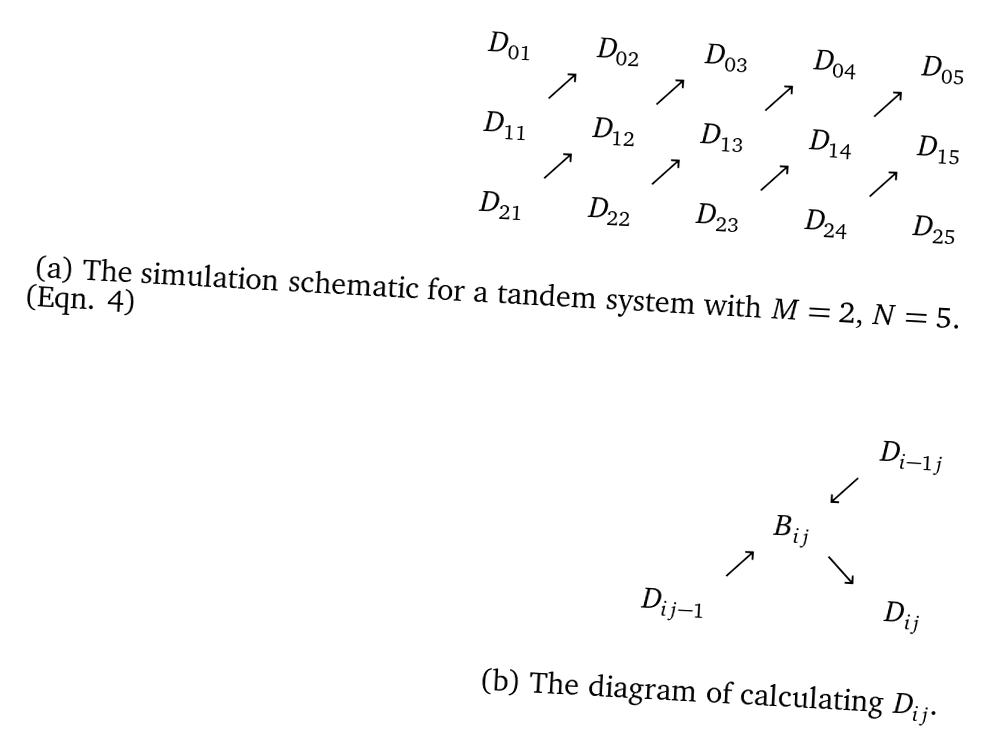Convert formula to latex. <formula><loc_0><loc_0><loc_500><loc_500>\begin{array} { c c c c c c c c c } D _ { 0 1 } & & D _ { 0 2 } & & D _ { 0 3 } & & D _ { 0 4 } & & D _ { 0 5 } \\ & \nearrow & & \nearrow & & \nearrow & & \nearrow & \\ D _ { 1 1 } & & D _ { 1 2 } & & D _ { 1 3 } & & D _ { 1 4 } & & D _ { 1 5 } \\ & \nearrow & & \nearrow & & \nearrow & & \nearrow & \\ D _ { 2 1 } & & D _ { 2 2 } & & D _ { 2 3 } & & D _ { 2 4 } & & D _ { 2 5 } \end{array} \\ \\ \text {(a) The simulation schematic for a tandem system with $ M=2, \, N=5$.} \\ \\ \\ \begin{array} { c c c c c } & & & & D _ { i - 1 j } \\ & & & \swarrow & \\ & & B _ { i j } & & \\ & \nearrow & & \searrow & \\ D _ { i j - 1 } & & & & D _ { i j } \end{array} \\ \\ \text {(b) The diagram of calculating $ D_{ij} $.} \\</formula> 